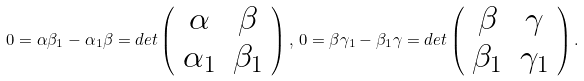<formula> <loc_0><loc_0><loc_500><loc_500>0 = \alpha \beta _ { 1 } - \alpha _ { 1 } \beta = d e t \left ( \begin{array} { c c } \alpha & \beta \\ \alpha _ { 1 } & \beta _ { 1 } \end{array} \right ) , \, 0 = \beta \gamma _ { 1 } - \beta _ { 1 } \gamma = d e t \left ( \begin{array} { c c } \beta & \gamma \\ \beta _ { 1 } & \gamma _ { 1 } \end{array} \right ) .</formula> 